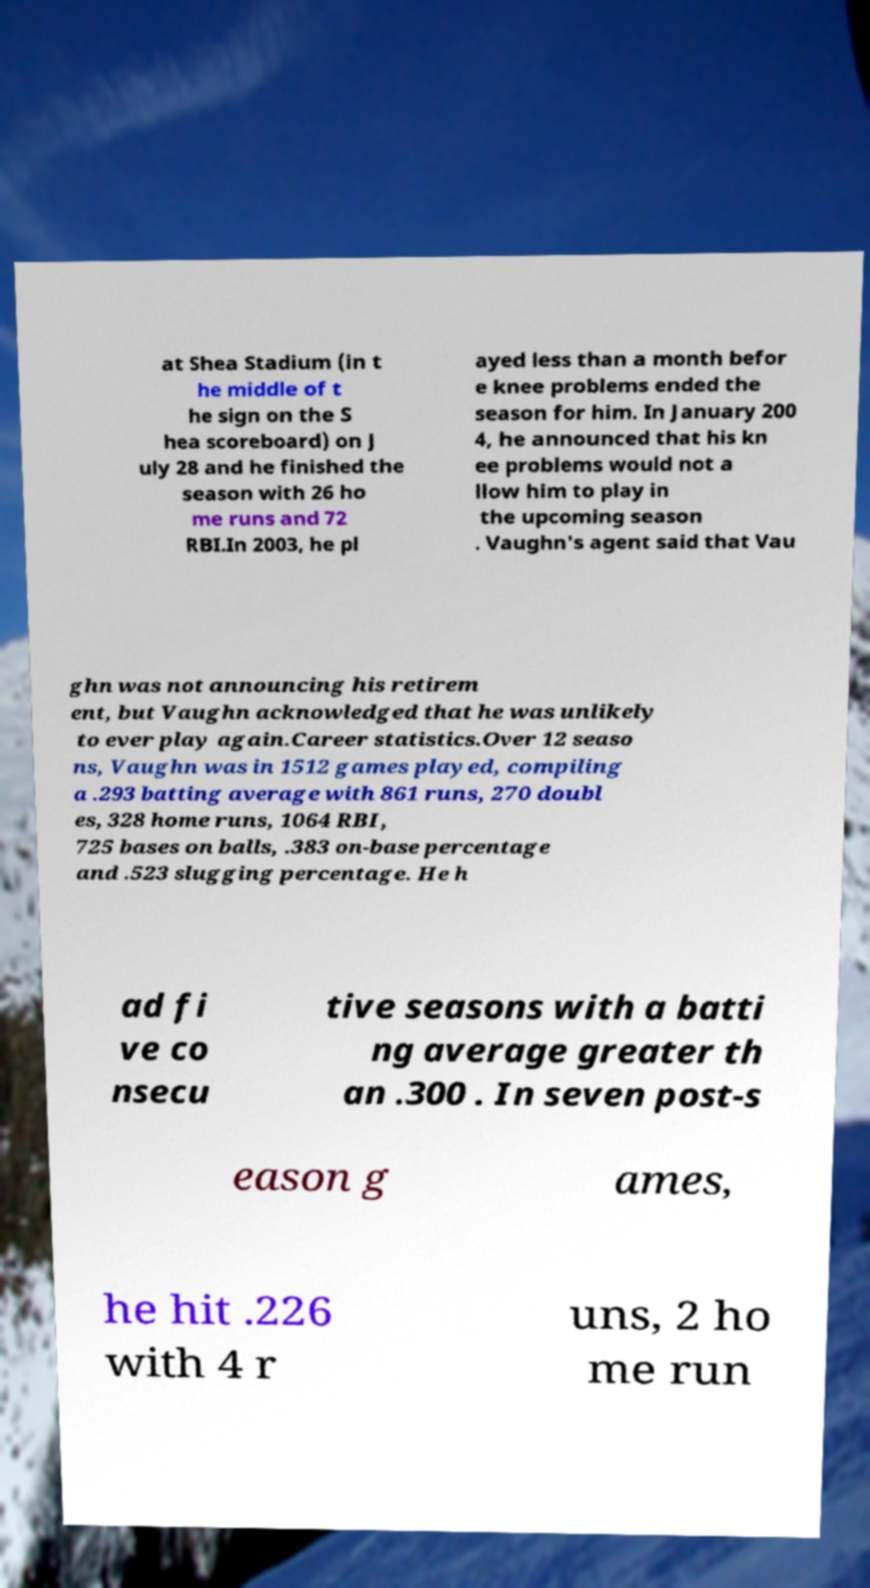Can you accurately transcribe the text from the provided image for me? at Shea Stadium (in t he middle of t he sign on the S hea scoreboard) on J uly 28 and he finished the season with 26 ho me runs and 72 RBI.In 2003, he pl ayed less than a month befor e knee problems ended the season for him. In January 200 4, he announced that his kn ee problems would not a llow him to play in the upcoming season . Vaughn's agent said that Vau ghn was not announcing his retirem ent, but Vaughn acknowledged that he was unlikely to ever play again.Career statistics.Over 12 seaso ns, Vaughn was in 1512 games played, compiling a .293 batting average with 861 runs, 270 doubl es, 328 home runs, 1064 RBI, 725 bases on balls, .383 on-base percentage and .523 slugging percentage. He h ad fi ve co nsecu tive seasons with a batti ng average greater th an .300 . In seven post-s eason g ames, he hit .226 with 4 r uns, 2 ho me run 